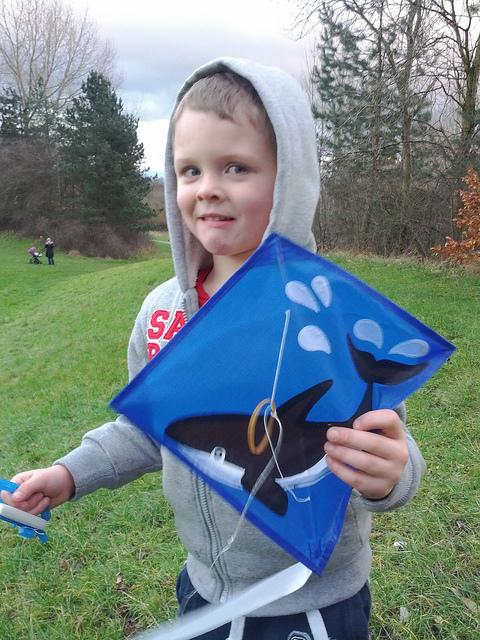What animal is on the kite?

Choices:
A) whale
B) echidna
C) dog
D) snake whale 